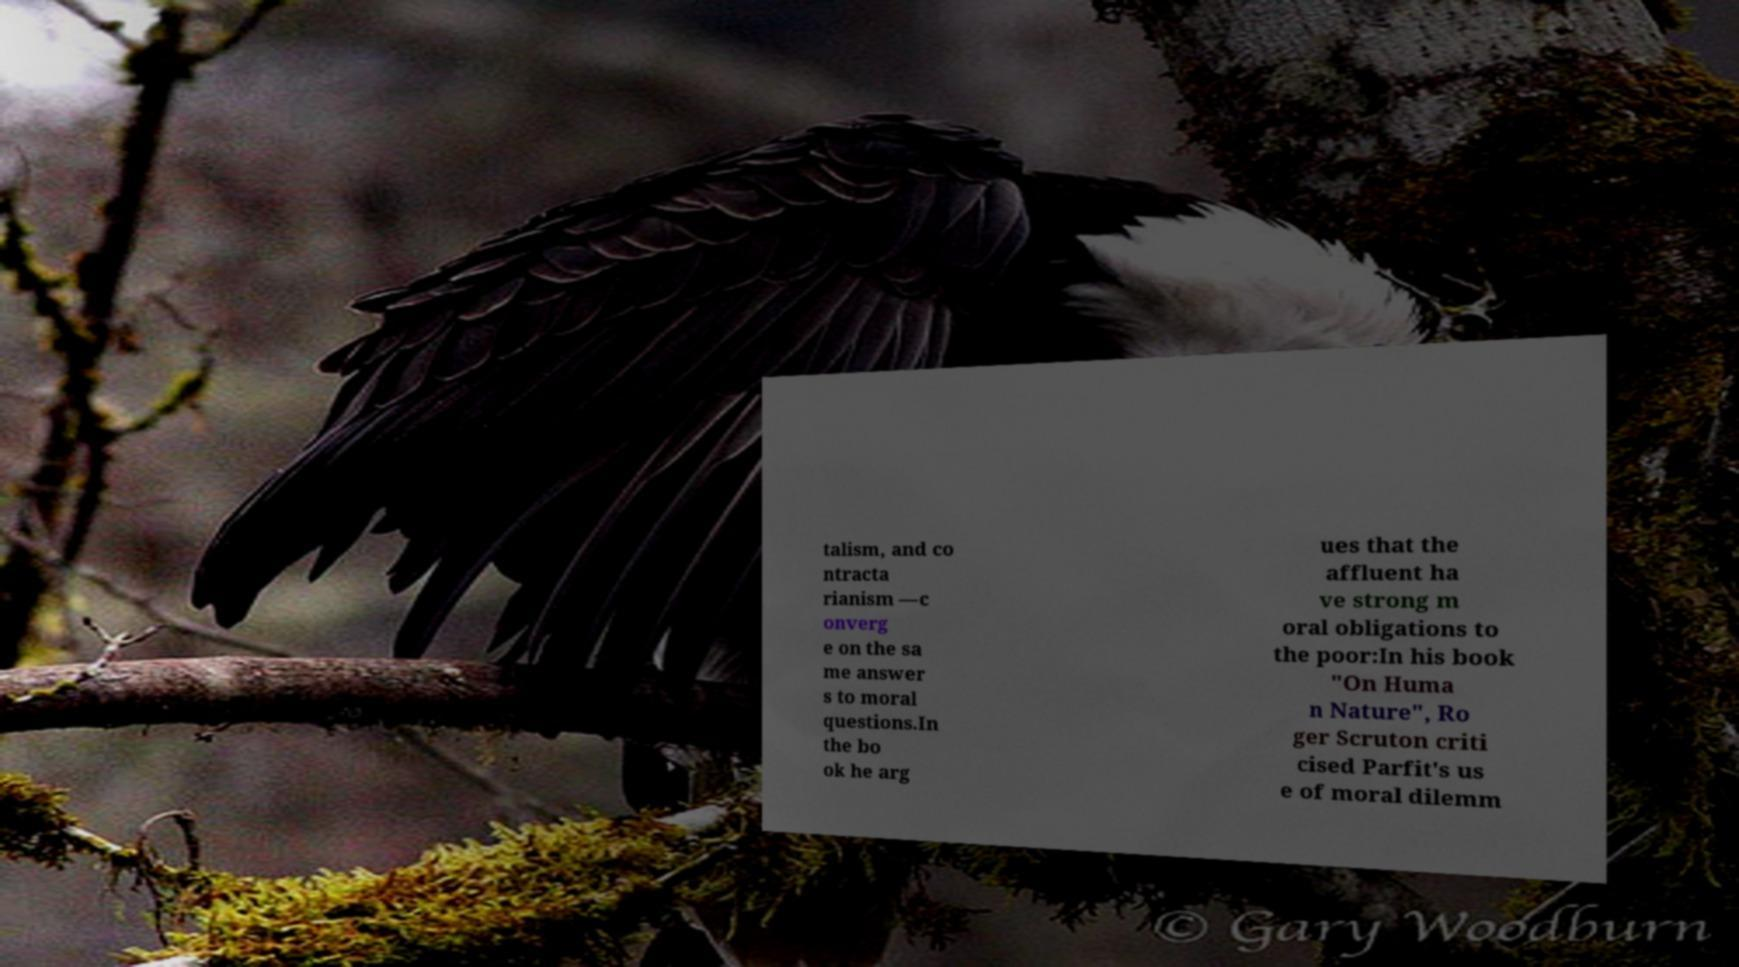I need the written content from this picture converted into text. Can you do that? talism, and co ntracta rianism —c onverg e on the sa me answer s to moral questions.In the bo ok he arg ues that the affluent ha ve strong m oral obligations to the poor:In his book "On Huma n Nature", Ro ger Scruton criti cised Parfit's us e of moral dilemm 